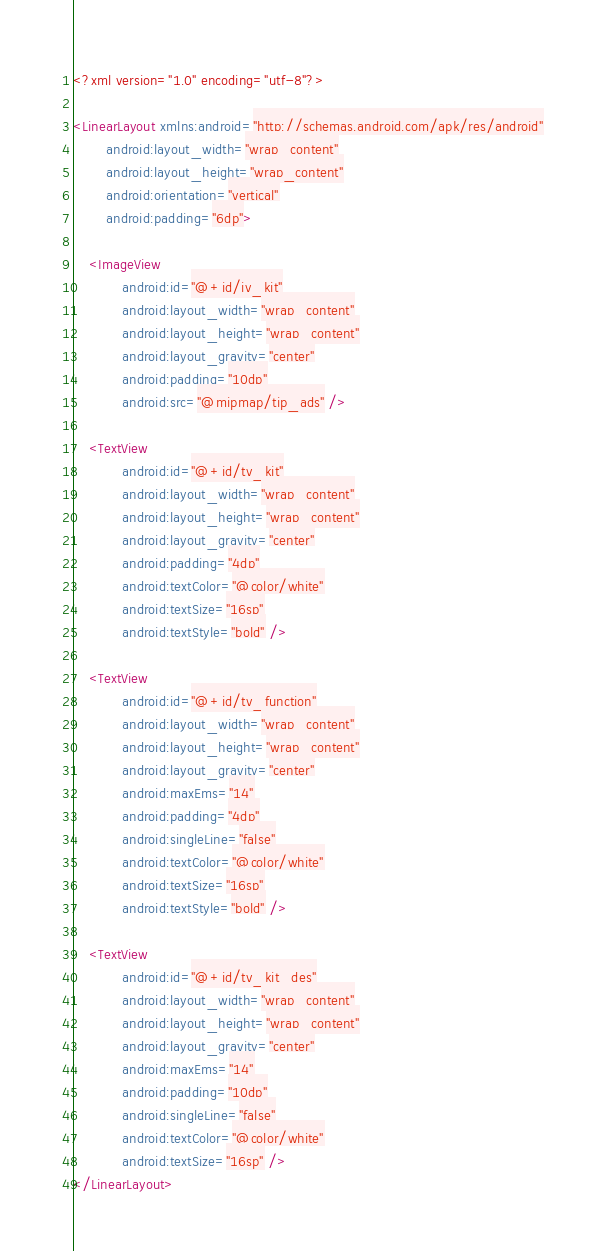<code> <loc_0><loc_0><loc_500><loc_500><_XML_><?xml version="1.0" encoding="utf-8"?>

<LinearLayout xmlns:android="http://schemas.android.com/apk/res/android"
        android:layout_width="wrap_content"
        android:layout_height="wrap_content"
        android:orientation="vertical"
        android:padding="6dp">

    <ImageView
            android:id="@+id/iv_kit"
            android:layout_width="wrap_content"
            android:layout_height="wrap_content"
            android:layout_gravity="center"
            android:padding="10dp"
            android:src="@mipmap/tip_ads" />

    <TextView
            android:id="@+id/tv_kit"
            android:layout_width="wrap_content"
            android:layout_height="wrap_content"
            android:layout_gravity="center"
            android:padding="4dp"
            android:textColor="@color/white"
            android:textSize="16sp"
            android:textStyle="bold" />

    <TextView
            android:id="@+id/tv_function"
            android:layout_width="wrap_content"
            android:layout_height="wrap_content"
            android:layout_gravity="center"
            android:maxEms="14"
            android:padding="4dp"
            android:singleLine="false"
            android:textColor="@color/white"
            android:textSize="16sp"
            android:textStyle="bold" />

    <TextView
            android:id="@+id/tv_kit_des"
            android:layout_width="wrap_content"
            android:layout_height="wrap_content"
            android:layout_gravity="center"
            android:maxEms="14"
            android:padding="10dp"
            android:singleLine="false"
            android:textColor="@color/white"
            android:textSize="16sp" />
</LinearLayout></code> 